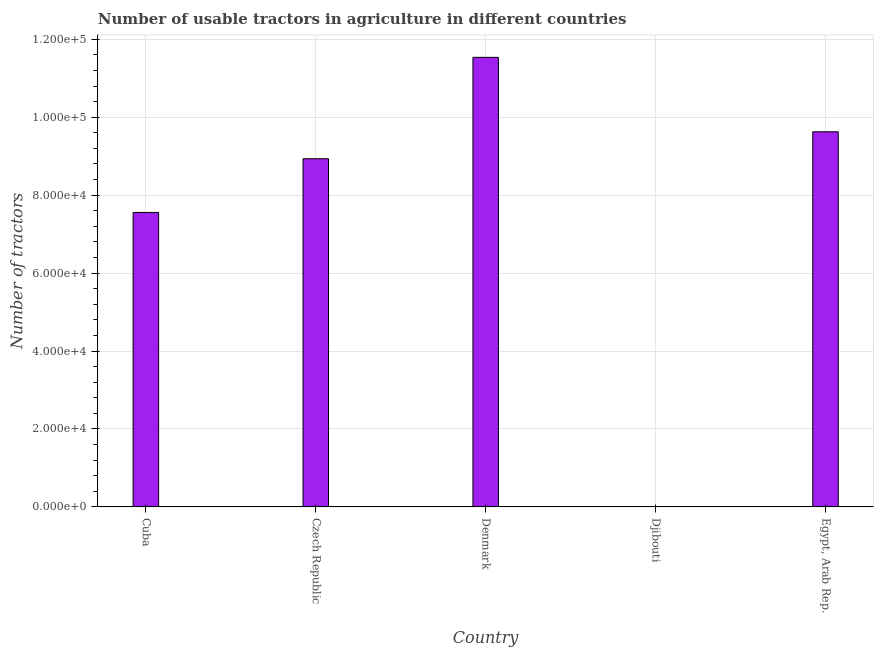Does the graph contain any zero values?
Offer a terse response. No. Does the graph contain grids?
Ensure brevity in your answer.  Yes. What is the title of the graph?
Your answer should be compact. Number of usable tractors in agriculture in different countries. What is the label or title of the X-axis?
Make the answer very short. Country. What is the label or title of the Y-axis?
Make the answer very short. Number of tractors. What is the number of tractors in Denmark?
Your response must be concise. 1.15e+05. Across all countries, what is the maximum number of tractors?
Ensure brevity in your answer.  1.15e+05. Across all countries, what is the minimum number of tractors?
Keep it short and to the point. 6. In which country was the number of tractors minimum?
Your answer should be very brief. Djibouti. What is the sum of the number of tractors?
Your answer should be very brief. 3.77e+05. What is the difference between the number of tractors in Cuba and Denmark?
Your answer should be very brief. -3.98e+04. What is the average number of tractors per country?
Your answer should be very brief. 7.53e+04. What is the median number of tractors?
Offer a terse response. 8.94e+04. In how many countries, is the number of tractors greater than 104000 ?
Keep it short and to the point. 1. What is the ratio of the number of tractors in Czech Republic to that in Egypt, Arab Rep.?
Give a very brief answer. 0.93. Is the number of tractors in Cuba less than that in Czech Republic?
Your answer should be compact. Yes. What is the difference between the highest and the second highest number of tractors?
Your answer should be compact. 1.91e+04. What is the difference between the highest and the lowest number of tractors?
Keep it short and to the point. 1.15e+05. In how many countries, is the number of tractors greater than the average number of tractors taken over all countries?
Your answer should be very brief. 4. How many bars are there?
Offer a terse response. 5. What is the difference between two consecutive major ticks on the Y-axis?
Your answer should be very brief. 2.00e+04. Are the values on the major ticks of Y-axis written in scientific E-notation?
Make the answer very short. Yes. What is the Number of tractors in Cuba?
Give a very brief answer. 7.56e+04. What is the Number of tractors of Czech Republic?
Your answer should be very brief. 8.94e+04. What is the Number of tractors in Denmark?
Ensure brevity in your answer.  1.15e+05. What is the Number of tractors in Egypt, Arab Rep.?
Keep it short and to the point. 9.63e+04. What is the difference between the Number of tractors in Cuba and Czech Republic?
Your response must be concise. -1.38e+04. What is the difference between the Number of tractors in Cuba and Denmark?
Make the answer very short. -3.98e+04. What is the difference between the Number of tractors in Cuba and Djibouti?
Your answer should be very brief. 7.56e+04. What is the difference between the Number of tractors in Cuba and Egypt, Arab Rep.?
Offer a terse response. -2.07e+04. What is the difference between the Number of tractors in Czech Republic and Denmark?
Provide a short and direct response. -2.60e+04. What is the difference between the Number of tractors in Czech Republic and Djibouti?
Provide a short and direct response. 8.93e+04. What is the difference between the Number of tractors in Czech Republic and Egypt, Arab Rep.?
Provide a succinct answer. -6915. What is the difference between the Number of tractors in Denmark and Djibouti?
Give a very brief answer. 1.15e+05. What is the difference between the Number of tractors in Denmark and Egypt, Arab Rep.?
Provide a short and direct response. 1.91e+04. What is the difference between the Number of tractors in Djibouti and Egypt, Arab Rep.?
Your answer should be compact. -9.63e+04. What is the ratio of the Number of tractors in Cuba to that in Czech Republic?
Your answer should be very brief. 0.85. What is the ratio of the Number of tractors in Cuba to that in Denmark?
Ensure brevity in your answer.  0.66. What is the ratio of the Number of tractors in Cuba to that in Djibouti?
Offer a terse response. 1.26e+04. What is the ratio of the Number of tractors in Cuba to that in Egypt, Arab Rep.?
Provide a short and direct response. 0.79. What is the ratio of the Number of tractors in Czech Republic to that in Denmark?
Provide a short and direct response. 0.78. What is the ratio of the Number of tractors in Czech Republic to that in Djibouti?
Provide a succinct answer. 1.49e+04. What is the ratio of the Number of tractors in Czech Republic to that in Egypt, Arab Rep.?
Keep it short and to the point. 0.93. What is the ratio of the Number of tractors in Denmark to that in Djibouti?
Ensure brevity in your answer.  1.92e+04. What is the ratio of the Number of tractors in Denmark to that in Egypt, Arab Rep.?
Your response must be concise. 1.2. What is the ratio of the Number of tractors in Djibouti to that in Egypt, Arab Rep.?
Offer a very short reply. 0. 